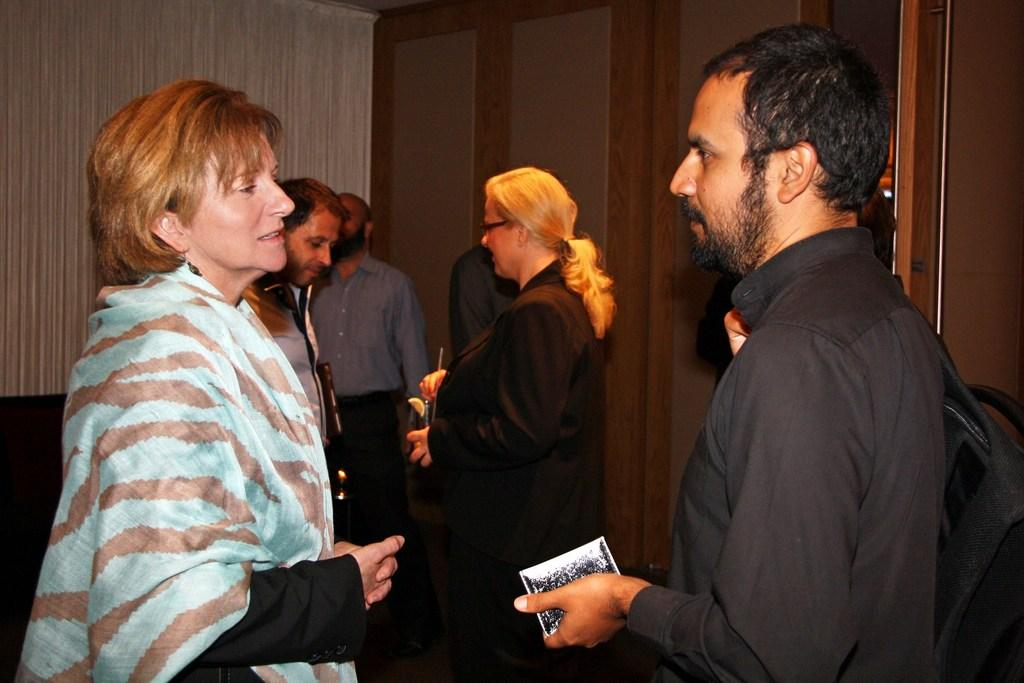How many people are in the image? There is a group of persons in the image. What are the persons in the image doing? The persons are standing and talking to each other. What can be seen in the background of the image? There is a wall and cupboards in the background of the image. What type of prose is being recited by the actor in the image? There is no actor or prose present in the image; it features a group of persons standing and talking to each other. 